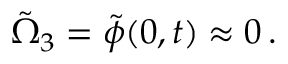Convert formula to latex. <formula><loc_0><loc_0><loc_500><loc_500>\tilde { \Omega } _ { 3 } = \tilde { \phi } ( 0 , t ) \approx 0 \, .</formula> 